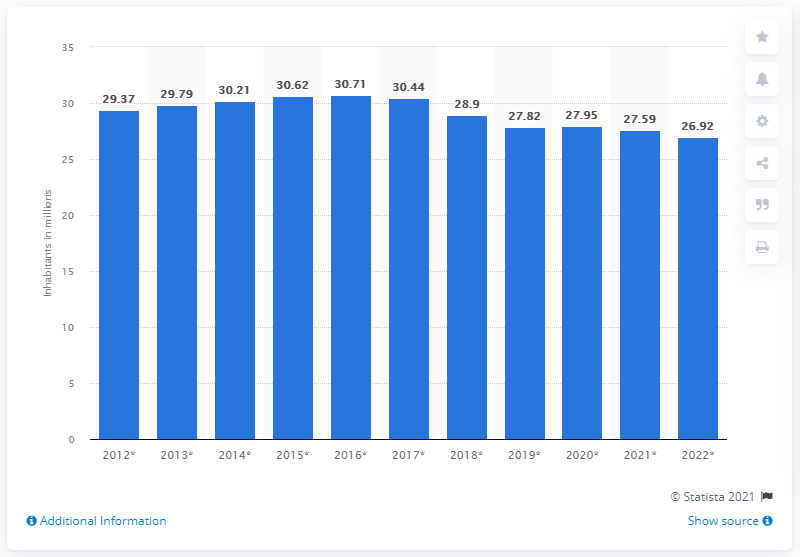Highlight a few significant elements in this photo. In 2020, the population of Venezuela was 27.95 million. 